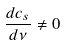Convert formula to latex. <formula><loc_0><loc_0><loc_500><loc_500>\frac { d c _ { s } } { d \nu } \neq 0</formula> 